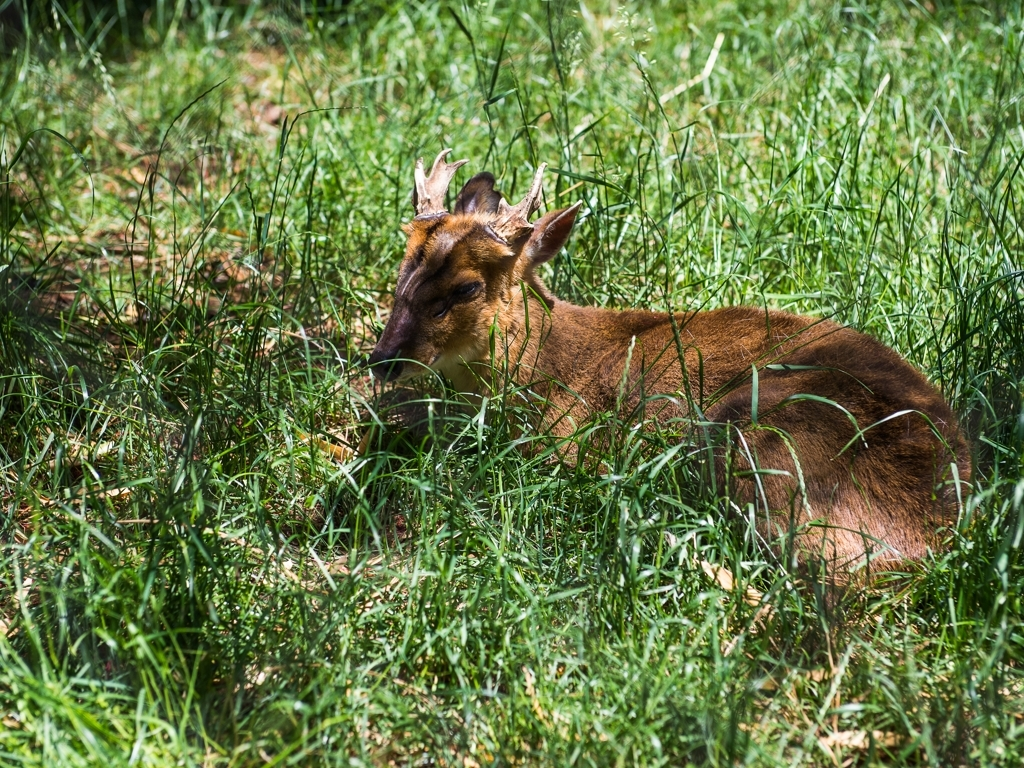What can you infer about the behavior of the deer in this image? The deer looks relaxed and alert, lying down while its head remains raised, which is common behavior when these animals are resting yet staying vigilant. The position indicates it could be ready to stand up quickly if it senses danger. This behavior is typical in open areas where there might be predators, and it suggests the deer is involved in a moment of rest while being attentive to its surroundings. 